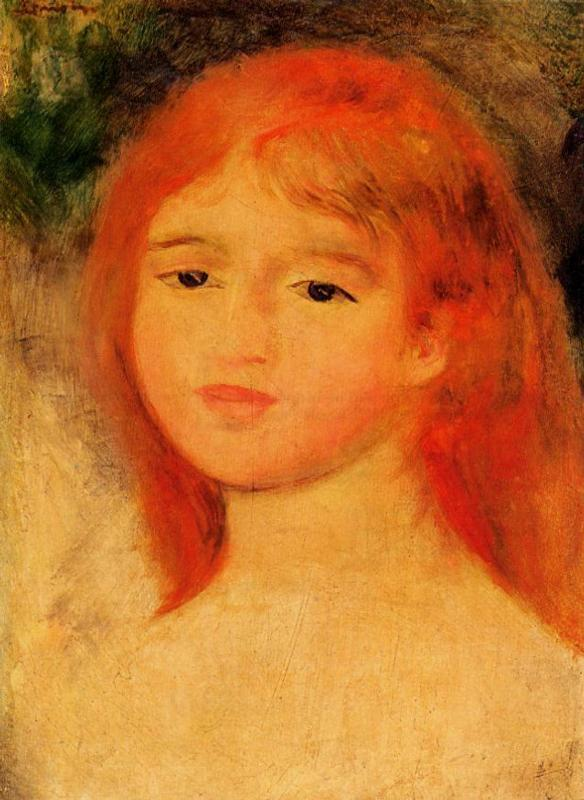How does the choice of colors influence the mood of this painting? The use of predominant warm tones of red and orange for the hair, coupled with the contrasting cool green and yellow background, establishes a vibrant yet soothing palette. This color choice enhances the painting's mood by imbuing it with energy and warmth while maintaining a peaceful and harmonious environment. The subtle blues in the background may also suggest a hint of melancholy, adding depth to the emotional complexity of the scene. Does the use of light in the painting add to its emotional impact? Absolutely. The impressionist style of using light enhances the emotional depth of the painting. The diffuse lighting softens the girl's features, adding a dreamy quality to her appearance. This lighting technique, combined with the vivid yet soft brushstrokes, plays a crucial role in evoking a sense of innocence and ephemeral beauty, contributing significantly to the emotional resonance of the artwork. 